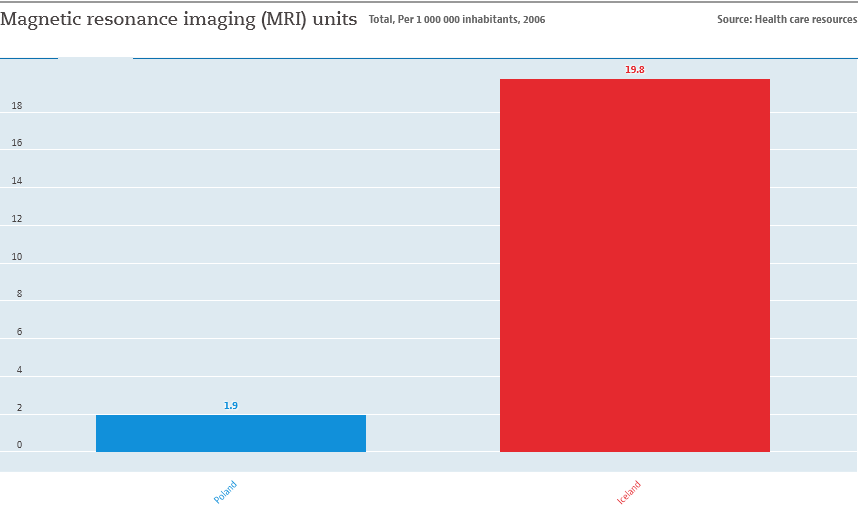Identify some key points in this picture. The value of the smallest bar is 1.9. The smallest bar value is not 11 times the value of the largest bar. 